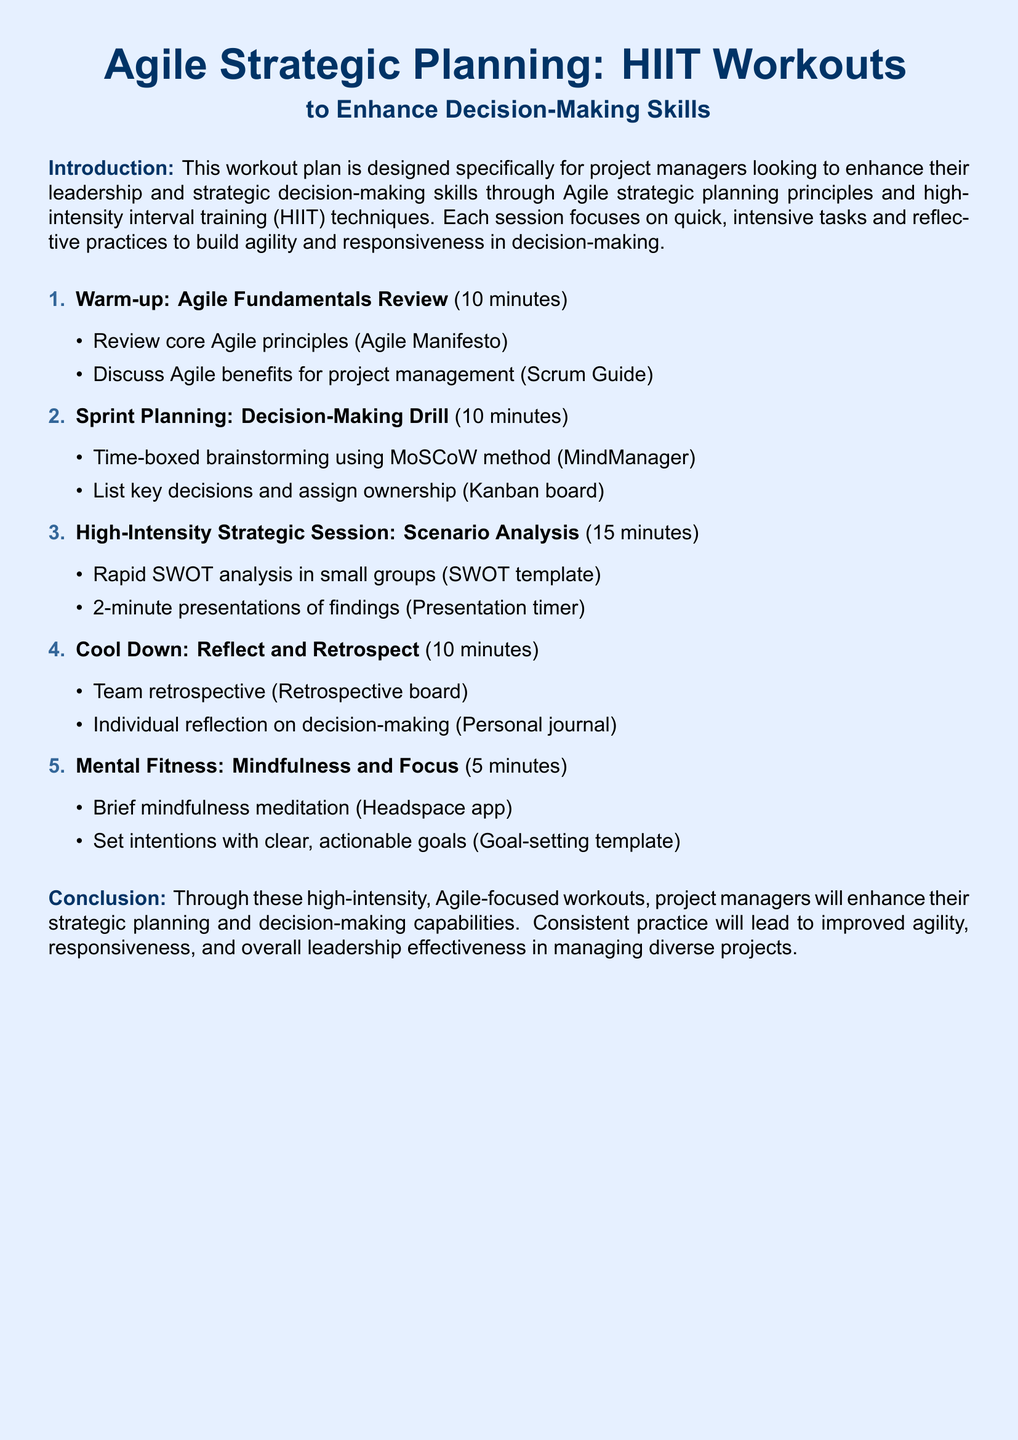What is the duration of the warm-up? The warm-up section lasts for 10 minutes as indicated in the document.
Answer: 10 minutes What method is used during the Sprint Planning session? The document specifies the MoSCoW method for the time-boxed brainstorming.
Answer: MoSCoW method How long is the High-Intensity Strategic Session? The duration of the High-Intensity Strategic Session is stated as 15 minutes.
Answer: 15 minutes What type of analysis is conducted during the High-Intensity Strategic Session? The document mentions a rapid SWOT analysis taking place in small groups.
Answer: SWOT analysis What is the final activity mentioned in the cool-down section? The last activity in the cool-down section is individual reflection on decision-making.
Answer: Individual reflection How long is the Mental Fitness session? The duration of the Mental Fitness session is mentioned as 5 minutes.
Answer: 5 minutes What app is recommended for the mindfulness meditation? The document specifies the Headspace app for the mindfulness meditation.
Answer: Headspace app What is the primary goal of the workout plan? The primary goal mentioned is to enhance strategic planning and decision-making capabilities.
Answer: Enhance strategic planning and decision-making capabilities 